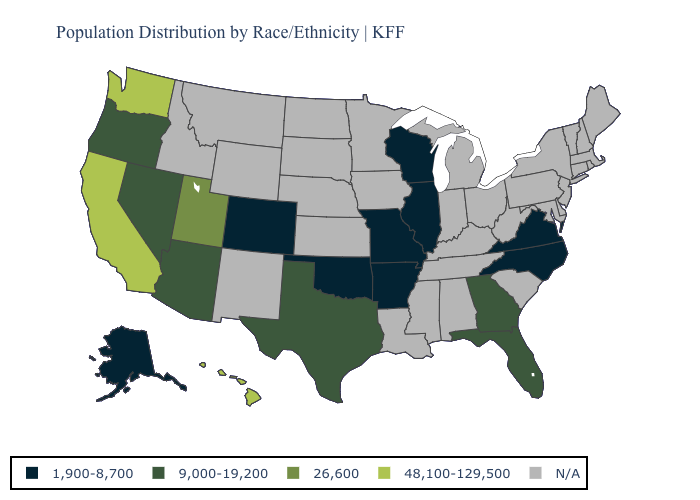Name the states that have a value in the range 26,600?
Give a very brief answer. Utah. What is the value of Ohio?
Short answer required. N/A. Does California have the highest value in the USA?
Short answer required. Yes. Name the states that have a value in the range N/A?
Answer briefly. Alabama, Connecticut, Delaware, Idaho, Indiana, Iowa, Kansas, Kentucky, Louisiana, Maine, Maryland, Massachusetts, Michigan, Minnesota, Mississippi, Montana, Nebraska, New Hampshire, New Jersey, New Mexico, New York, North Dakota, Ohio, Pennsylvania, Rhode Island, South Carolina, South Dakota, Tennessee, Vermont, West Virginia, Wyoming. Does Utah have the highest value in the West?
Write a very short answer. No. Which states have the highest value in the USA?
Write a very short answer. California, Hawaii, Washington. What is the value of Mississippi?
Answer briefly. N/A. Does Oklahoma have the lowest value in the South?
Answer briefly. Yes. What is the lowest value in the MidWest?
Keep it brief. 1,900-8,700. Does Washington have the highest value in the USA?
Give a very brief answer. Yes. What is the lowest value in the West?
Concise answer only. 1,900-8,700. Does North Carolina have the lowest value in the South?
Write a very short answer. Yes. Among the states that border Virginia , which have the lowest value?
Concise answer only. North Carolina. Does the map have missing data?
Answer briefly. Yes. 